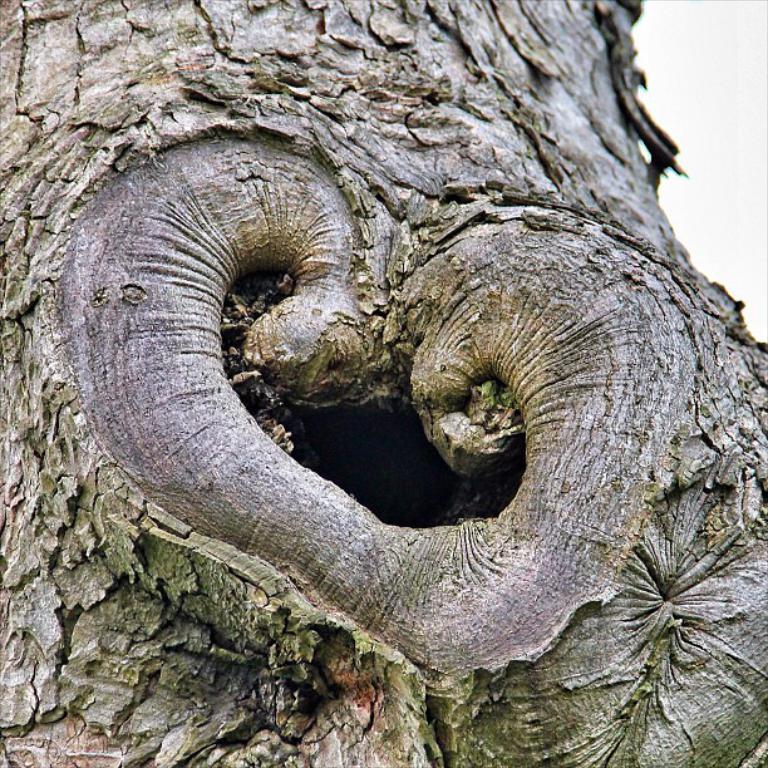How would you summarize this image in a sentence or two? In this image we can see a trunk on the bark of a tree. 